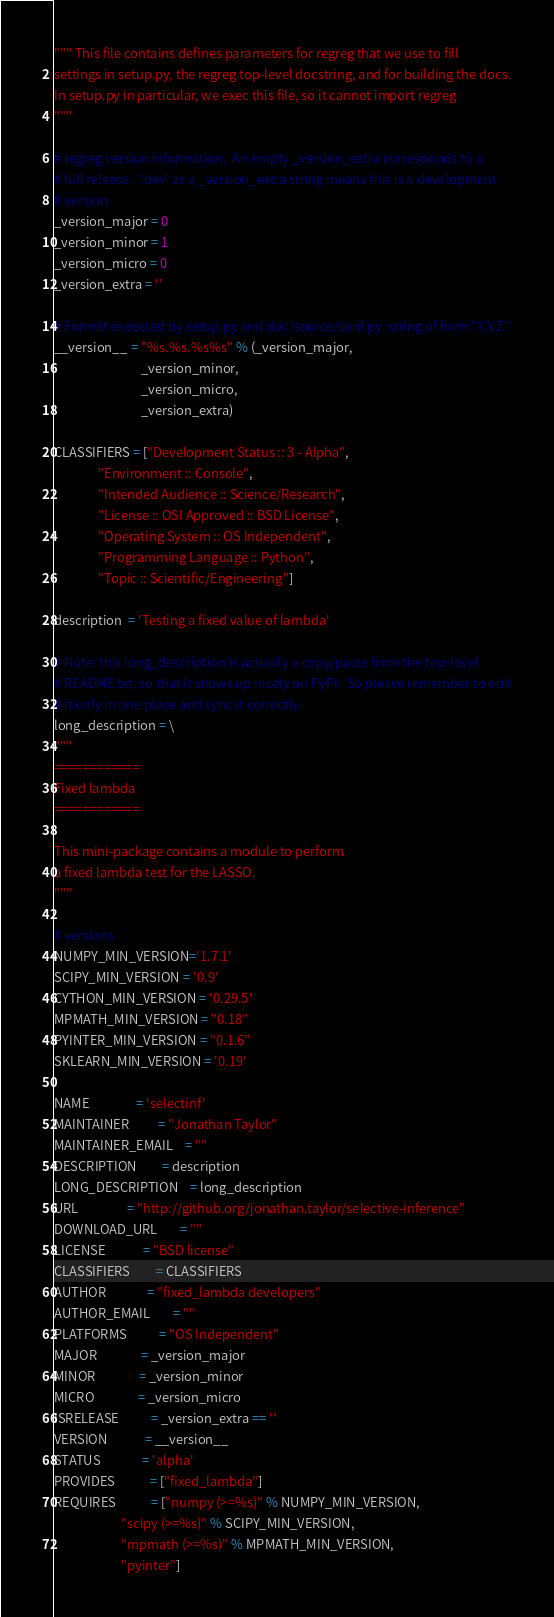Convert code to text. <code><loc_0><loc_0><loc_500><loc_500><_Python_>""" This file contains defines parameters for regreg that we use to fill
settings in setup.py, the regreg top-level docstring, and for building the docs.
In setup.py in particular, we exec this file, so it cannot import regreg
"""

# regreg version information.  An empty _version_extra corresponds to a
# full release.  '.dev' as a _version_extra string means this is a development
# version
_version_major = 0
_version_minor = 1
_version_micro = 0
_version_extra = ''

# Format expected by setup.py and doc/source/conf.py: string of form "X.Y.Z"
__version__ = "%s.%s.%s%s" % (_version_major,
                              _version_minor,
                              _version_micro,
                              _version_extra)

CLASSIFIERS = ["Development Status :: 3 - Alpha",
               "Environment :: Console",
               "Intended Audience :: Science/Research",
               "License :: OSI Approved :: BSD License",
               "Operating System :: OS Independent",
               "Programming Language :: Python",
               "Topic :: Scientific/Engineering"]

description  = 'Testing a fixed value of lambda'

# Note: this long_description is actually a copy/paste from the top-level
# README.txt, so that it shows up nicely on PyPI.  So please remember to edit
# it only in one place and sync it correctly.
long_description = \
"""
============
Fixed lambda
============

This mini-package contains a module to perform
a fixed lambda test for the LASSO.
"""

# versions
NUMPY_MIN_VERSION='1.7.1'
SCIPY_MIN_VERSION = '0.9'
CYTHON_MIN_VERSION = '0.29.5'
MPMATH_MIN_VERSION = "0.18"
PYINTER_MIN_VERSION = "0.1.6"
SKLEARN_MIN_VERSION = '0.19'

NAME                = 'selectinf'
MAINTAINER          = "Jonathan Taylor"
MAINTAINER_EMAIL    = ""
DESCRIPTION         = description
LONG_DESCRIPTION    = long_description
URL                 = "http://github.org/jonathan.taylor/selective-inference"
DOWNLOAD_URL        = ""
LICENSE             = "BSD license"
CLASSIFIERS         = CLASSIFIERS
AUTHOR              = "fixed_lambda developers"
AUTHOR_EMAIL        = ""
PLATFORMS           = "OS Independent"
MAJOR               = _version_major
MINOR               = _version_minor
MICRO               = _version_micro
ISRELEASE           = _version_extra == ''
VERSION             = __version__
STATUS              = 'alpha'
PROVIDES            = ["fixed_lambda"]
REQUIRES            = ["numpy (>=%s)" % NUMPY_MIN_VERSION,
                       "scipy (>=%s)" % SCIPY_MIN_VERSION,
                       "mpmath (>=%s)" % MPMATH_MIN_VERSION,
                       "pyinter"]
</code> 